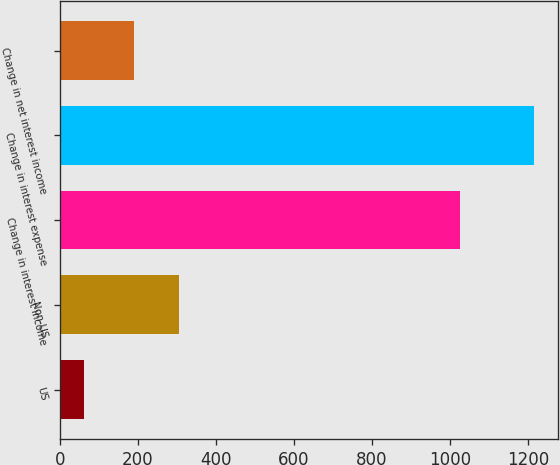Convert chart to OTSL. <chart><loc_0><loc_0><loc_500><loc_500><bar_chart><fcel>US<fcel>Non-US<fcel>Change in interest income<fcel>Change in interest expense<fcel>Change in net interest income<nl><fcel>62<fcel>306.4<fcel>1025<fcel>1216<fcel>191<nl></chart> 